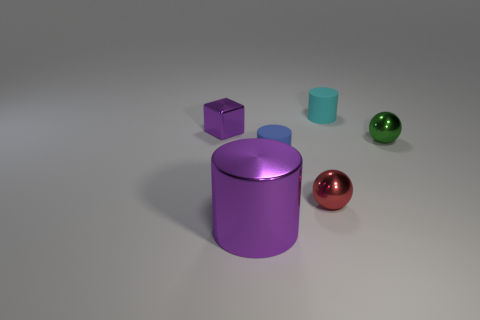How many shiny objects are either small cylinders or small brown objects?
Ensure brevity in your answer.  0. What is the color of the matte thing that is the same size as the blue matte cylinder?
Keep it short and to the point. Cyan. How many small purple objects have the same shape as the cyan rubber object?
Your response must be concise. 0. What number of balls are big purple objects or tiny metal objects?
Keep it short and to the point. 2. Does the tiny red object that is in front of the small blue cylinder have the same shape as the purple object that is behind the purple metal cylinder?
Make the answer very short. No. What is the large purple cylinder made of?
Keep it short and to the point. Metal. What is the shape of the metallic object that is the same color as the large shiny cylinder?
Keep it short and to the point. Cube. How many green things have the same size as the red ball?
Your answer should be compact. 1. How many things are shiny balls to the left of the small green thing or things to the left of the red metallic thing?
Provide a short and direct response. 4. Do the tiny object behind the metallic block and the small sphere behind the blue cylinder have the same material?
Make the answer very short. No. 